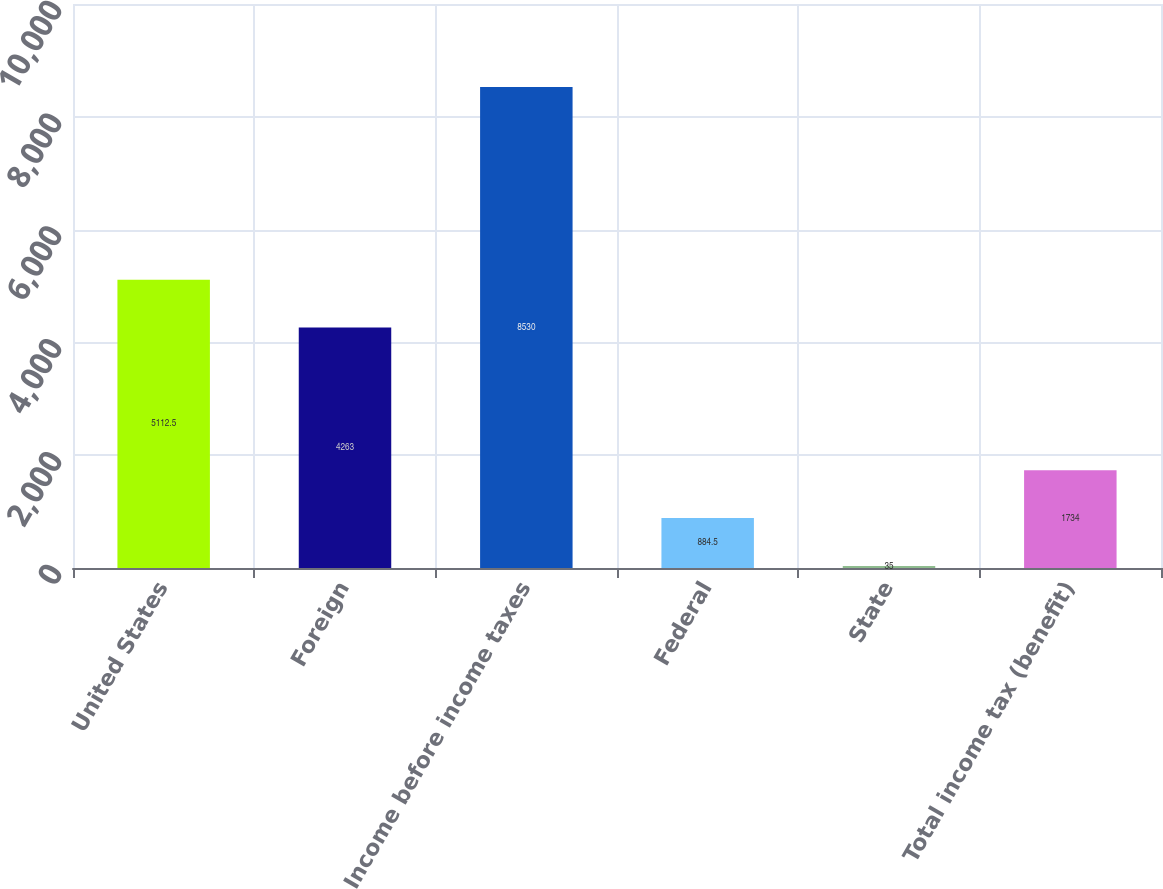<chart> <loc_0><loc_0><loc_500><loc_500><bar_chart><fcel>United States<fcel>Foreign<fcel>Income before income taxes<fcel>Federal<fcel>State<fcel>Total income tax (benefit)<nl><fcel>5112.5<fcel>4263<fcel>8530<fcel>884.5<fcel>35<fcel>1734<nl></chart> 